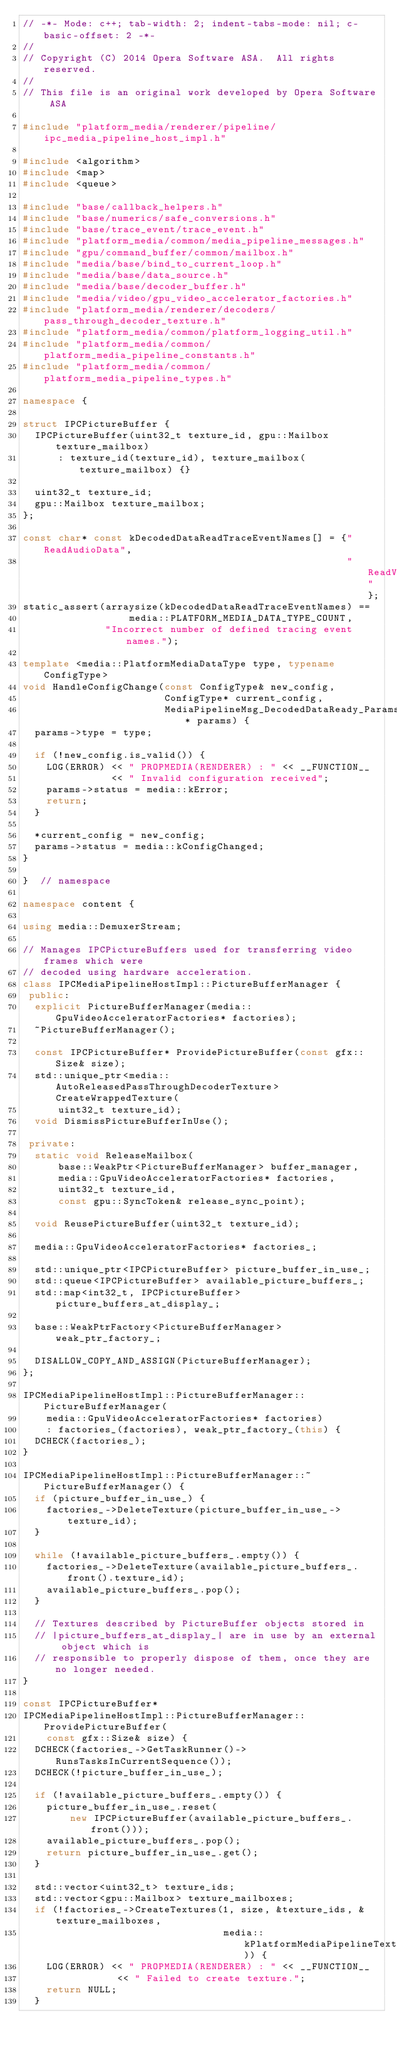<code> <loc_0><loc_0><loc_500><loc_500><_C++_>// -*- Mode: c++; tab-width: 2; indent-tabs-mode: nil; c-basic-offset: 2 -*-
//
// Copyright (C) 2014 Opera Software ASA.  All rights reserved.
//
// This file is an original work developed by Opera Software ASA

#include "platform_media/renderer/pipeline/ipc_media_pipeline_host_impl.h"

#include <algorithm>
#include <map>
#include <queue>

#include "base/callback_helpers.h"
#include "base/numerics/safe_conversions.h"
#include "base/trace_event/trace_event.h"
#include "platform_media/common/media_pipeline_messages.h"
#include "gpu/command_buffer/common/mailbox.h"
#include "media/base/bind_to_current_loop.h"
#include "media/base/data_source.h"
#include "media/base/decoder_buffer.h"
#include "media/video/gpu_video_accelerator_factories.h"
#include "platform_media/renderer/decoders/pass_through_decoder_texture.h"
#include "platform_media/common/platform_logging_util.h"
#include "platform_media/common/platform_media_pipeline_constants.h"
#include "platform_media/common/platform_media_pipeline_types.h"

namespace {

struct IPCPictureBuffer {
  IPCPictureBuffer(uint32_t texture_id, gpu::Mailbox texture_mailbox)
      : texture_id(texture_id), texture_mailbox(texture_mailbox) {}

  uint32_t texture_id;
  gpu::Mailbox texture_mailbox;
};

const char* const kDecodedDataReadTraceEventNames[] = {"ReadAudioData",
                                                       "ReadVideoData"};
static_assert(arraysize(kDecodedDataReadTraceEventNames) ==
                  media::PLATFORM_MEDIA_DATA_TYPE_COUNT,
              "Incorrect number of defined tracing event names.");

template <media::PlatformMediaDataType type, typename ConfigType>
void HandleConfigChange(const ConfigType& new_config,
                        ConfigType* current_config,
                        MediaPipelineMsg_DecodedDataReady_Params* params) {
  params->type = type;

  if (!new_config.is_valid()) {
    LOG(ERROR) << " PROPMEDIA(RENDERER) : " << __FUNCTION__
               << " Invalid configuration received";
    params->status = media::kError;
    return;
  }

  *current_config = new_config;
  params->status = media::kConfigChanged;
}

}  // namespace

namespace content {

using media::DemuxerStream;

// Manages IPCPictureBuffers used for transferring video frames which were
// decoded using hardware acceleration.
class IPCMediaPipelineHostImpl::PictureBufferManager {
 public:
  explicit PictureBufferManager(media::GpuVideoAcceleratorFactories* factories);
  ~PictureBufferManager();

  const IPCPictureBuffer* ProvidePictureBuffer(const gfx::Size& size);
  std::unique_ptr<media::AutoReleasedPassThroughDecoderTexture> CreateWrappedTexture(
      uint32_t texture_id);
  void DismissPictureBufferInUse();

 private:
  static void ReleaseMailbox(
      base::WeakPtr<PictureBufferManager> buffer_manager,
      media::GpuVideoAcceleratorFactories* factories,
      uint32_t texture_id,
      const gpu::SyncToken& release_sync_point);

  void ReusePictureBuffer(uint32_t texture_id);

  media::GpuVideoAcceleratorFactories* factories_;

  std::unique_ptr<IPCPictureBuffer> picture_buffer_in_use_;
  std::queue<IPCPictureBuffer> available_picture_buffers_;
  std::map<int32_t, IPCPictureBuffer> picture_buffers_at_display_;

  base::WeakPtrFactory<PictureBufferManager> weak_ptr_factory_;

  DISALLOW_COPY_AND_ASSIGN(PictureBufferManager);
};

IPCMediaPipelineHostImpl::PictureBufferManager::PictureBufferManager(
    media::GpuVideoAcceleratorFactories* factories)
    : factories_(factories), weak_ptr_factory_(this) {
  DCHECK(factories_);
}

IPCMediaPipelineHostImpl::PictureBufferManager::~PictureBufferManager() {
  if (picture_buffer_in_use_) {
    factories_->DeleteTexture(picture_buffer_in_use_->texture_id);
  }

  while (!available_picture_buffers_.empty()) {
    factories_->DeleteTexture(available_picture_buffers_.front().texture_id);
    available_picture_buffers_.pop();
  }

  // Textures described by PictureBuffer objects stored in
  // |picture_buffers_at_display_| are in use by an external object which is
  // responsible to properly dispose of them, once they are no longer needed.
}

const IPCPictureBuffer*
IPCMediaPipelineHostImpl::PictureBufferManager::ProvidePictureBuffer(
    const gfx::Size& size) {
  DCHECK(factories_->GetTaskRunner()->RunsTasksInCurrentSequence());
  DCHECK(!picture_buffer_in_use_);

  if (!available_picture_buffers_.empty()) {
    picture_buffer_in_use_.reset(
        new IPCPictureBuffer(available_picture_buffers_.front()));
    available_picture_buffers_.pop();
    return picture_buffer_in_use_.get();
  }

  std::vector<uint32_t> texture_ids;
  std::vector<gpu::Mailbox> texture_mailboxes;
  if (!factories_->CreateTextures(1, size, &texture_ids, &texture_mailboxes,
                                  media::kPlatformMediaPipelineTextureTarget)) {
    LOG(ERROR) << " PROPMEDIA(RENDERER) : " << __FUNCTION__
                << " Failed to create texture.";
    return NULL;
  }</code> 